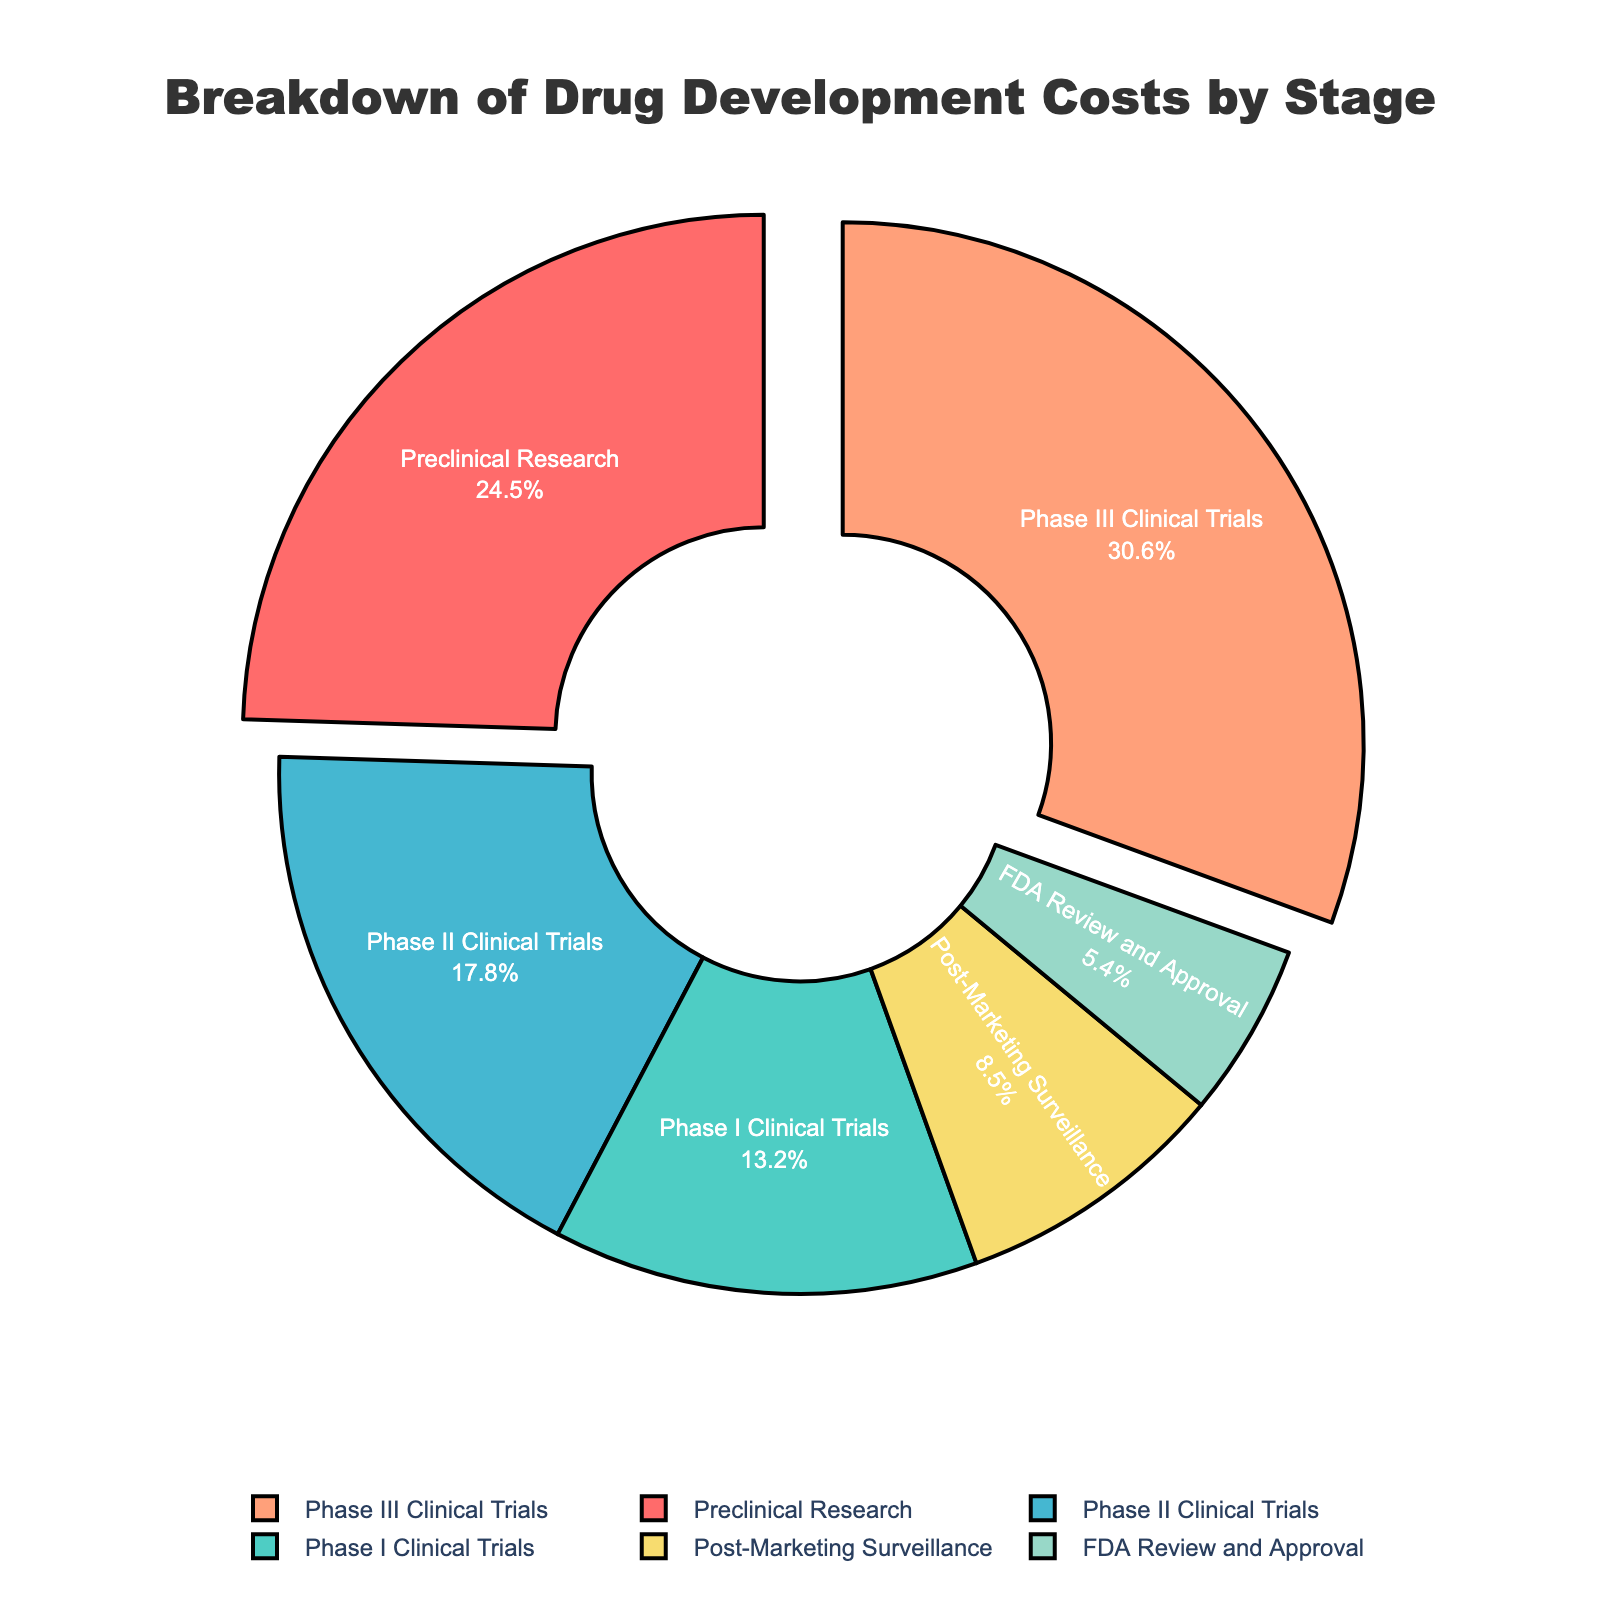what stage of drug development incurs the highest cost? The figure shows a pie chart with different stages of drug development and their respective percentages. The slice with the largest percentage indicates the highest cost. In this case, "Phase III Clinical Trials" has the highest percentage at 30.6%.
Answer: Phase III Clinical Trials What is the combined cost percentage for preclinical research and Phase I Clinical Trials? To find the combined cost percentage, sum the percentages for "Preclinical Research" and "Phase I Clinical Trials". Adding 24.5% (Preclinical Research) and 13.2% (Phase I Clinical Trials) gives 37.7%.
Answer: 37.7% Which stages of drug development cumulatively account for more than 50% of the costs? To determine this, add the percentages starting from the highest until the cumulative sum exceeds 50%. Summing 30.6% (Phase III Clinical Trials), 24.5% (Preclinical Research), and 17.8% (Phase II Clinical Trials) results in 72.9%, which exceeds 50%.
Answer: Phase III Clinical Trials, Preclinical Research, Phase II Clinical Trials Is the cost for post-marketing surveillance greater or less than the cost for FDA review and approval? The percentage for "Post-Marketing Surveillance" is 8.5%, while for "FDA Review and Approval" it is 5.4%. Since 8.5% is greater than 5.4%, the cost for post-marketing surveillance is greater.
Answer: Greater What percentage of the costs are incurred by the clinical trial phases (Phase I, II, and III)? To find the total cost percentage for the clinical trial phases, sum the percentages for Phase I, Phase II, and Phase III. Summing 13.2% (Phase I), 17.8% (Phase II), and 30.6% (Phase III) gives 61.6%.
Answer: 61.6% Which stage has the smallest share of the drug development cost, and what is its percentage? The smallest slice on the pie chart represents the stage with the least cost. "FDA Review and Approval" has the smallest share, with a percentage of 5.4%.
Answer: FDA Review and Approval, 5.4% How much higher is the cost percentage of Phase III Clinical Trials compared to Phase II Clinical Trials? Subtract the percentage for Phase II Clinical Trials from that of Phase III Clinical Trials. The difference is 30.6% (Phase III) - 17.8% (Phase II) = 12.8%.
Answer: 12.8% If the costs for Preclinical Research and Post-Marketing Surveillance were combined, would their total be greater than the cost for Phase III Clinical Trials? Sum the percentages for Preclinical Research and Post-Marketing Surveillance, then compare to Phase III Clinical Trials. Adding 24.5% (Preclinical Research) and 8.5% (Post-Marketing Surveillance) gives 33.0%, which is greater than 30.6% for Phase III Clinical Trials.
Answer: Yes What is the percentage difference between the highest and lowest drug development cost stages? The highest percentage is for Phase III Clinical Trials at 30.6%, and the lowest is for FDA Review and Approval at 5.4%. Subtract 5.4 from 30.6 to find the difference: 30.6 - 5.4 = 25.2%.
Answer: 25.2% 